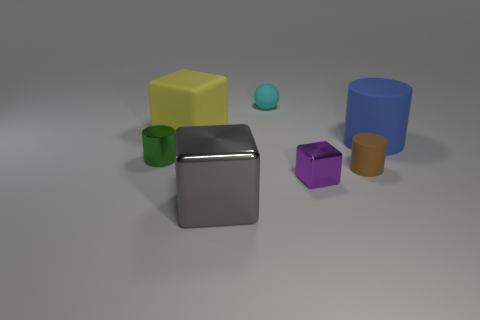What number of other things are the same size as the gray shiny thing? 2 